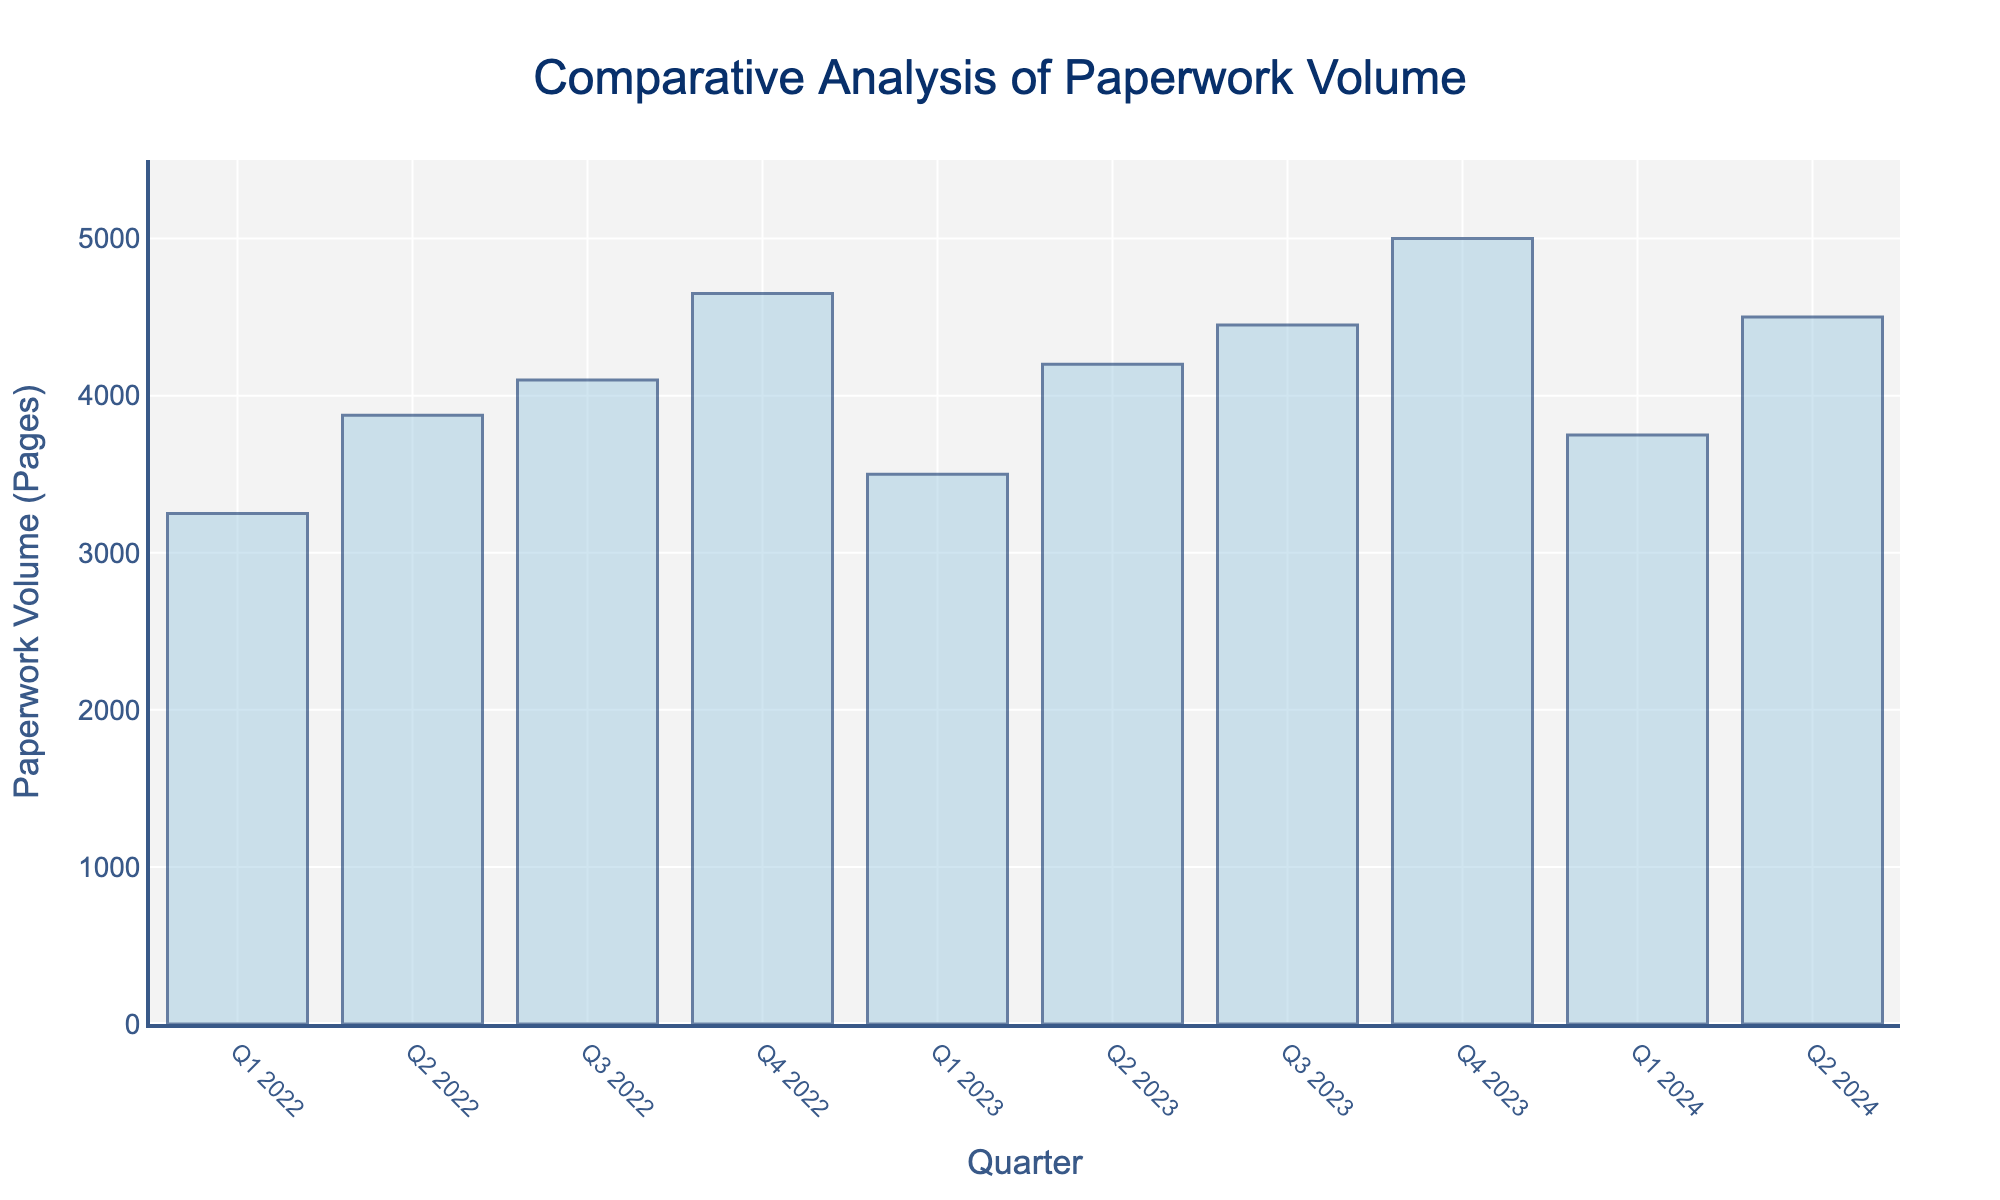What is the total paperwork volume in 2022? To find the total paperwork volume for 2022, sum the individual values for each quarter in 2022. (3250 + 3875 + 4100 + 4650)
Answer: 15875 How does the paperwork volume in Q1 2023 compare to Q1 2022? Subtract the Q1 2022 volume from Q1 2023 volume to find the difference. (3500 - 3250)
Answer: 250 pages more in Q1 2023 Which quarter had the highest paperwork volume? Identify the highest bar in the chart. This bar represents Q4 2023 with a volume of 5000 pages.
Answer: Q4 2023 What is the average paperwork volume per quarter in 2023? Sum the volumes for all quarters in 2023 and divide by the number of quarters. (3500 + 4200 + 4450 + 5000) / 4 = 17150 / 4
Answer: 4287.5 pages Compare the paperwork volume between Q4 2023 and Q4 2022. Subtract Q4 2022 volume from Q4 2023 volume. (5000 - 4650)
Answer: 350 pages more in Q4 2023 Across all the visualized data, what is the smallest paperwork volume recorded, and in which quarter? Identify the shortest bar in the chart, representing the smallest volume. This bar is Q1 2022 with a volume of 3250 pages.
Answer: 3250 pages in Q1 2022 Calculate the total paperwork volume for Q2 across all available years (2022, 2023, 2024). Sum the volumes for Q2 2022, Q2 2023, and Q2 2024. (3875 + 4200 + 4500)
Answer: 12575 What is the change in paperwork volume from Q2 2023 to Q3 2023? Subtract Q2 2023 volume from Q3 2023 volume. (4450 - 4200)
Answer: 250 pages How does the paperwork volume in Q1 2024 compare to Q1 2023? Subtract the Q1 2023 volume from Q1 2024 volume to find the difference. (3750 - 3500)
Answer: 250 pages more in Q1 2024 